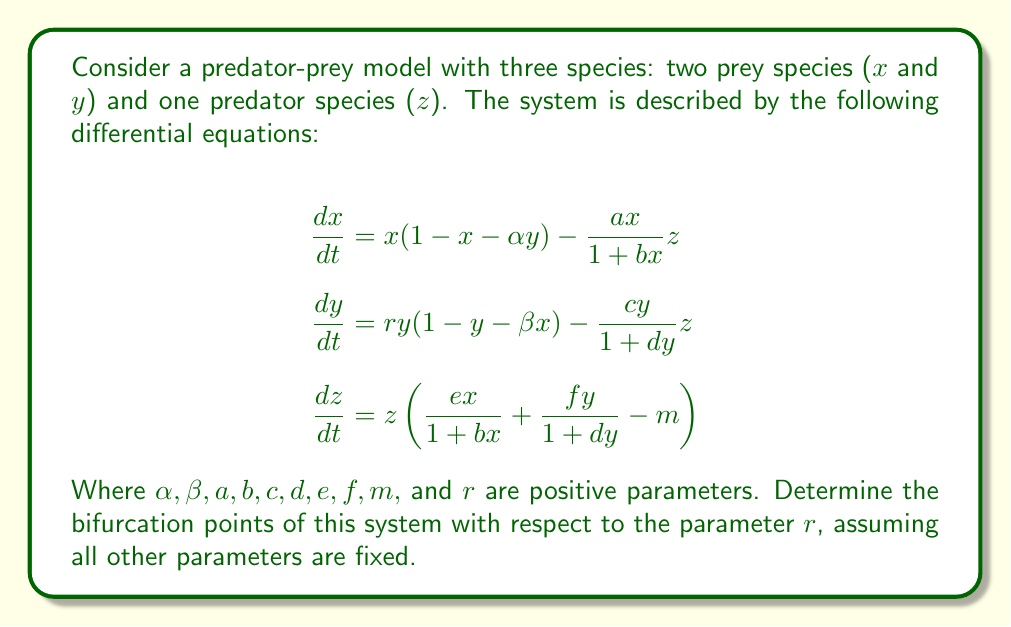Could you help me with this problem? To find the bifurcation points, we need to follow these steps:

1) Find the equilibrium points of the system by setting all derivatives to zero:

   $$\begin{align}
   x(1 - x - \alpha y) - \frac{ax}{1 + bx}z &= 0 \\
   ry(1 - y - \beta x) - \frac{cy}{1 + dy}z &= 0 \\
   z\left(\frac{ex}{1 + bx} + \frac{fy}{1 + dy} - m\right) &= 0
   \end{align}$$

2) From the third equation, we can see that either $z = 0$ or $\frac{ex}{1 + bx} + \frac{fy}{1 + dy} = m$.

3) For $z = 0$, we get two equilibrium points:
   - $(0, 0, 0)$: trivial equilibrium
   - $(1, 0, 0)$: prey 1 only equilibrium

4) For $\frac{ex}{1 + bx} + \frac{fy}{1 + dy} = m$, we need to solve the system numerically to find the coexistence equilibrium $(x^*, y^*, z^*)$.

5) To determine the stability of these equilibria and find bifurcation points, we need to compute the Jacobian matrix:

   $$J = \begin{bmatrix}
   1 - 2x - \alpha y - \frac{az(1+bx) - abxz}{(1+bx)^2} & -\alpha x & -\frac{ax}{1+bx} \\
   -\beta ry & r(1 - 2y - \beta x) - \frac{cz(1+dy) - cdyz}{(1+dy)^2} & -\frac{cy}{1+dy} \\
   \frac{ez(1+bx) - ebxz}{(1+bx)^2} & \frac{fz(1+dy) - fdyz}{(1+dy)^2} & \frac{ex}{1+bx} + \frac{fy}{1+dy} - m
   \end{bmatrix}$$

6) Evaluate the Jacobian at each equilibrium point and find its eigenvalues. Bifurcation occurs when the real part of an eigenvalue changes sign.

7) For the trivial equilibrium $(0, 0, 0)$, the Jacobian simplifies to:

   $$J_{(0,0,0)} = \begin{bmatrix}
   1 & 0 & 0 \\
   0 & r & 0 \\
   0 & 0 & -m
   \end{bmatrix}$$

   The eigenvalues are $1, r,$ and $-m$. A bifurcation occurs when $r = 0$.

8) For the prey 1 only equilibrium $(1, 0, 0)$, the Jacobian is:

   $$J_{(1,0,0)} = \begin{bmatrix}
   -1 & -\alpha & -\frac{a}{1+b} \\
   0 & r(1-\beta) & 0 \\
   0 & 0 & \frac{e}{1+b} - m
   \end{bmatrix}$$

   A bifurcation occurs when $r(1-\beta) = 0$, i.e., when $r = \frac{1}{\beta}$.

9) For the coexistence equilibrium $(x^*, y^*, z^*)$, we need to evaluate the Jacobian numerically and find the values of $r$ where the real parts of the eigenvalues change sign.

Therefore, we have identified two analytical bifurcation points: $r = 0$ and $r = \frac{1}{\beta}$. Additional bifurcation points may exist for the coexistence equilibrium, which would require numerical analysis.
Answer: $r = 0$ and $r = \frac{1}{\beta}$ 